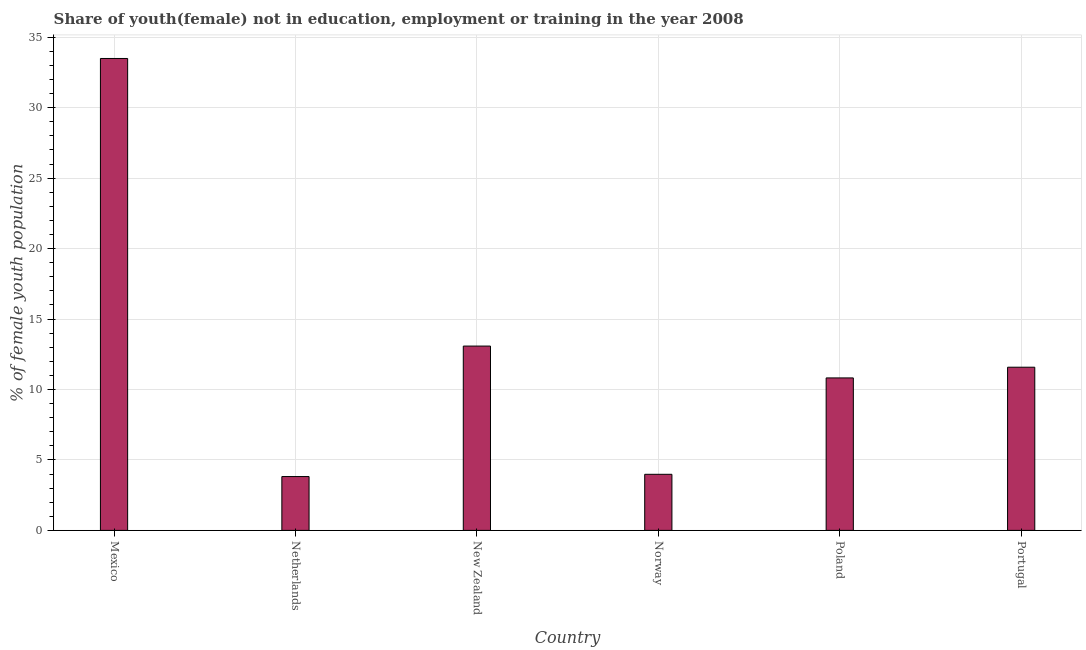What is the title of the graph?
Offer a very short reply. Share of youth(female) not in education, employment or training in the year 2008. What is the label or title of the Y-axis?
Keep it short and to the point. % of female youth population. What is the unemployed female youth population in Portugal?
Offer a very short reply. 11.58. Across all countries, what is the maximum unemployed female youth population?
Ensure brevity in your answer.  33.49. Across all countries, what is the minimum unemployed female youth population?
Your response must be concise. 3.82. In which country was the unemployed female youth population maximum?
Ensure brevity in your answer.  Mexico. What is the sum of the unemployed female youth population?
Offer a very short reply. 76.77. What is the difference between the unemployed female youth population in Netherlands and Poland?
Keep it short and to the point. -7. What is the average unemployed female youth population per country?
Provide a succinct answer. 12.79. What is the median unemployed female youth population?
Ensure brevity in your answer.  11.2. What is the ratio of the unemployed female youth population in Norway to that in Poland?
Provide a short and direct response. 0.37. Is the unemployed female youth population in Mexico less than that in Portugal?
Your answer should be very brief. No. What is the difference between the highest and the second highest unemployed female youth population?
Provide a short and direct response. 20.41. What is the difference between the highest and the lowest unemployed female youth population?
Ensure brevity in your answer.  29.67. How many bars are there?
Offer a terse response. 6. How many countries are there in the graph?
Your answer should be compact. 6. What is the % of female youth population in Mexico?
Your answer should be very brief. 33.49. What is the % of female youth population of Netherlands?
Your answer should be very brief. 3.82. What is the % of female youth population of New Zealand?
Offer a terse response. 13.08. What is the % of female youth population of Norway?
Your response must be concise. 3.98. What is the % of female youth population of Poland?
Provide a succinct answer. 10.82. What is the % of female youth population in Portugal?
Provide a short and direct response. 11.58. What is the difference between the % of female youth population in Mexico and Netherlands?
Give a very brief answer. 29.67. What is the difference between the % of female youth population in Mexico and New Zealand?
Ensure brevity in your answer.  20.41. What is the difference between the % of female youth population in Mexico and Norway?
Provide a short and direct response. 29.51. What is the difference between the % of female youth population in Mexico and Poland?
Offer a terse response. 22.67. What is the difference between the % of female youth population in Mexico and Portugal?
Ensure brevity in your answer.  21.91. What is the difference between the % of female youth population in Netherlands and New Zealand?
Your answer should be compact. -9.26. What is the difference between the % of female youth population in Netherlands and Norway?
Provide a succinct answer. -0.16. What is the difference between the % of female youth population in Netherlands and Portugal?
Give a very brief answer. -7.76. What is the difference between the % of female youth population in New Zealand and Poland?
Provide a succinct answer. 2.26. What is the difference between the % of female youth population in New Zealand and Portugal?
Your answer should be compact. 1.5. What is the difference between the % of female youth population in Norway and Poland?
Your response must be concise. -6.84. What is the difference between the % of female youth population in Poland and Portugal?
Your answer should be very brief. -0.76. What is the ratio of the % of female youth population in Mexico to that in Netherlands?
Your answer should be very brief. 8.77. What is the ratio of the % of female youth population in Mexico to that in New Zealand?
Offer a terse response. 2.56. What is the ratio of the % of female youth population in Mexico to that in Norway?
Your answer should be compact. 8.41. What is the ratio of the % of female youth population in Mexico to that in Poland?
Your answer should be compact. 3.1. What is the ratio of the % of female youth population in Mexico to that in Portugal?
Provide a short and direct response. 2.89. What is the ratio of the % of female youth population in Netherlands to that in New Zealand?
Keep it short and to the point. 0.29. What is the ratio of the % of female youth population in Netherlands to that in Poland?
Offer a very short reply. 0.35. What is the ratio of the % of female youth population in Netherlands to that in Portugal?
Ensure brevity in your answer.  0.33. What is the ratio of the % of female youth population in New Zealand to that in Norway?
Make the answer very short. 3.29. What is the ratio of the % of female youth population in New Zealand to that in Poland?
Ensure brevity in your answer.  1.21. What is the ratio of the % of female youth population in New Zealand to that in Portugal?
Give a very brief answer. 1.13. What is the ratio of the % of female youth population in Norway to that in Poland?
Provide a short and direct response. 0.37. What is the ratio of the % of female youth population in Norway to that in Portugal?
Offer a terse response. 0.34. What is the ratio of the % of female youth population in Poland to that in Portugal?
Ensure brevity in your answer.  0.93. 